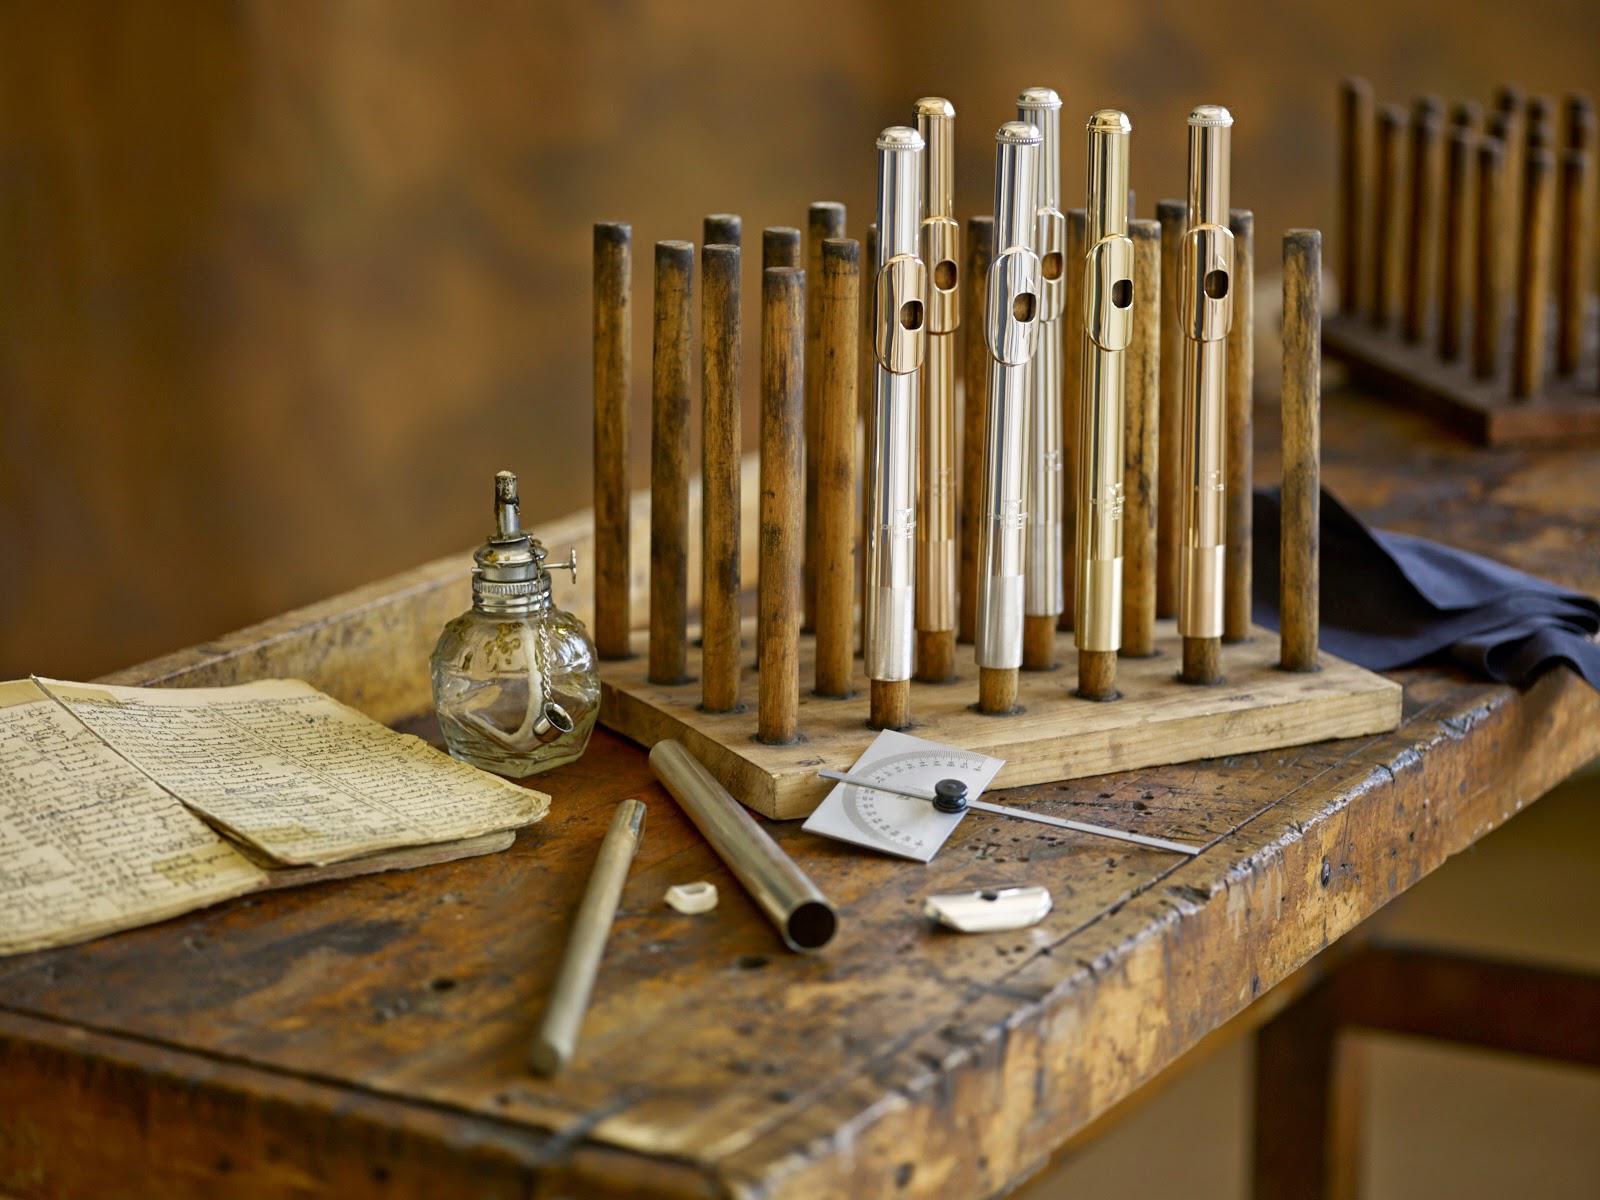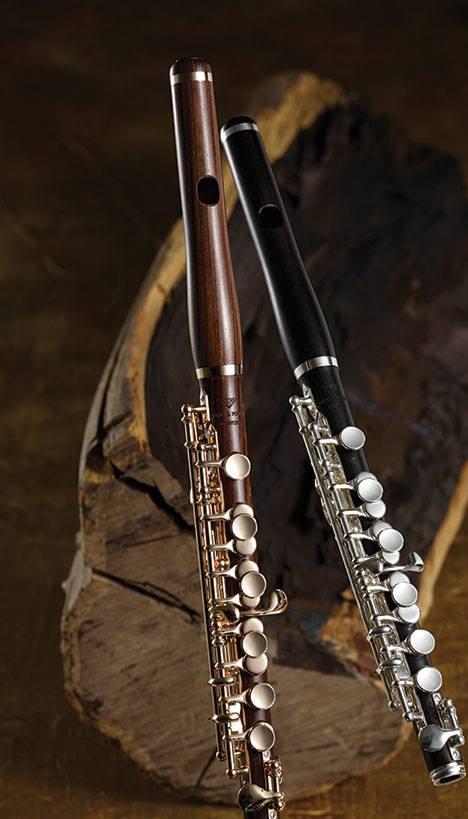The first image is the image on the left, the second image is the image on the right. Examine the images to the left and right. Is the description "There are exactly two flutes in the right image." accurate? Answer yes or no. Yes. The first image is the image on the left, the second image is the image on the right. Assess this claim about the two images: "There is only one instrument in the left image.". Correct or not? Answer yes or no. No. 